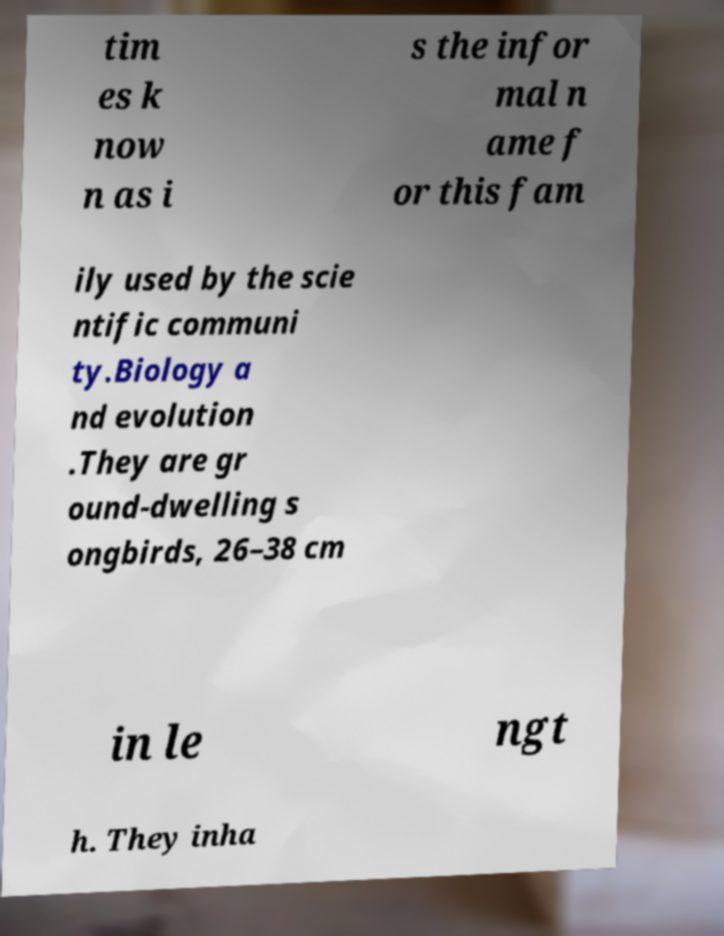There's text embedded in this image that I need extracted. Can you transcribe it verbatim? tim es k now n as i s the infor mal n ame f or this fam ily used by the scie ntific communi ty.Biology a nd evolution .They are gr ound-dwelling s ongbirds, 26–38 cm in le ngt h. They inha 